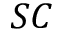Convert formula to latex. <formula><loc_0><loc_0><loc_500><loc_500>S C</formula> 